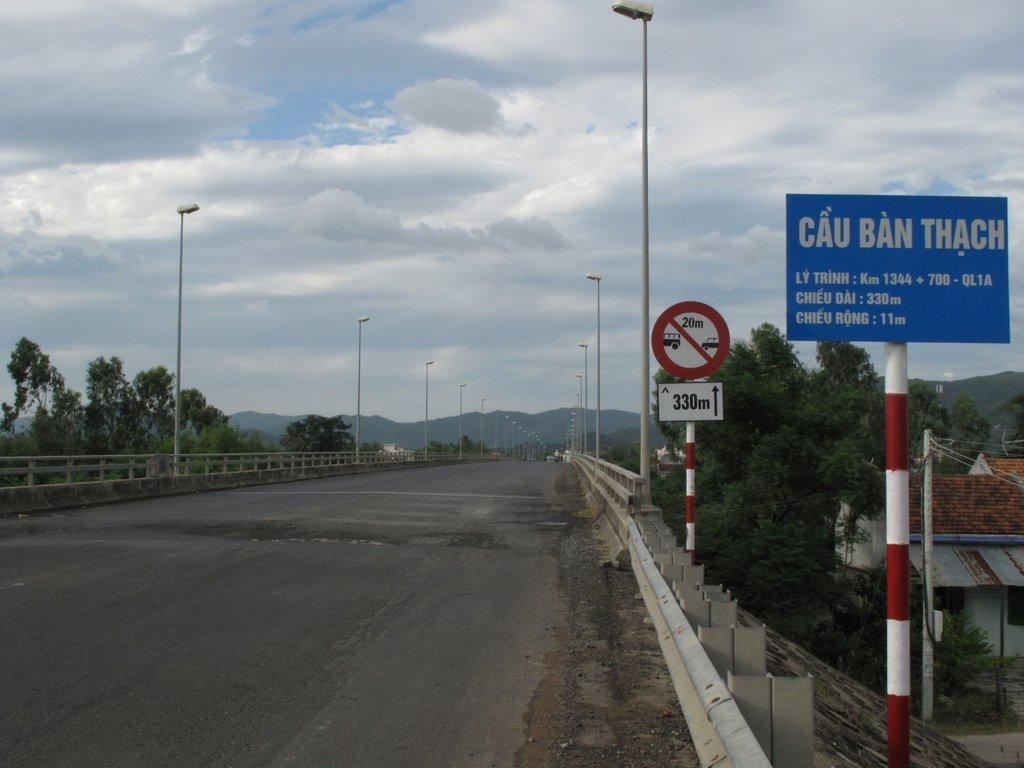<image>
Render a clear and concise summary of the photo. A road sign that says Cau Ban Thach on it. 